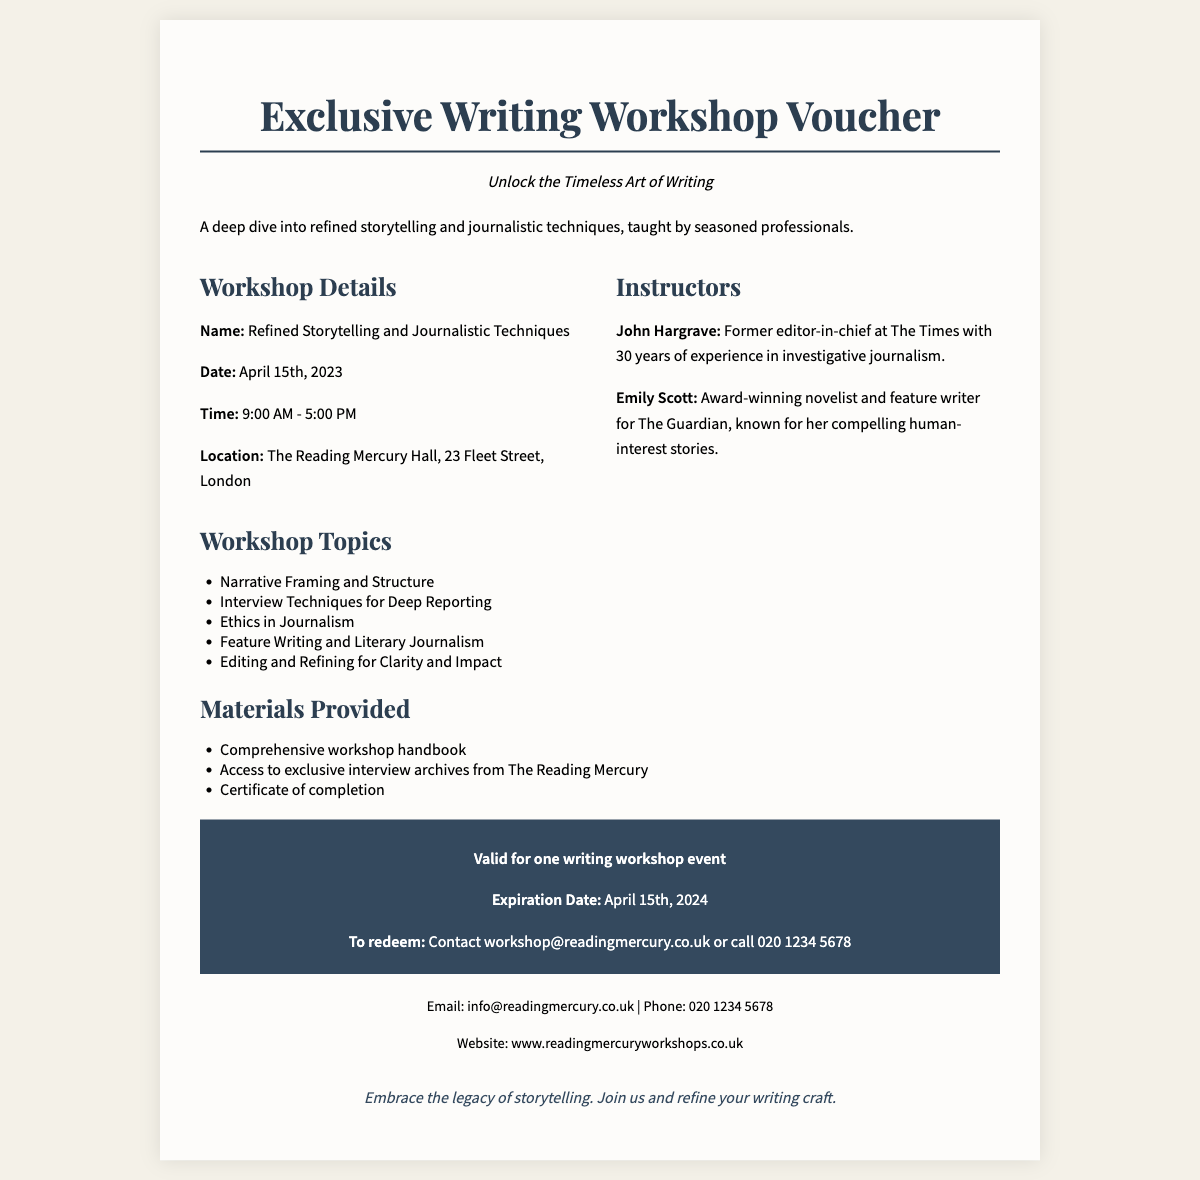What is the workshop name? The workshop name is found in the details section of the voucher document.
Answer: Refined Storytelling and Journalistic Techniques What is the date of the workshop? The date of the workshop is specifically stated in the details section.
Answer: April 15th, 2023 Who are the instructors? The instructors are listed under the instructors section of the document.
Answer: John Hargrave and Emily Scott What are the workshop hours? The workshop hours are mentioned in the details section, indicating the start and end time.
Answer: 9:00 AM - 5:00 PM What is the expiration date of the voucher? The expiration date is clearly mentioned in the validity section of the voucher.
Answer: April 15th, 2024 What materials will be provided? The materials provided are listed in a dedicated section of the document.
Answer: Comprehensive workshop handbook, Access to exclusive interview archives from The Reading Mercury, Certificate of completion Which skill will be focused on during the workshop? The skills/topics of the workshop are enumerated to highlight specific areas of focus.
Answer: Narrative Framing and Structure How can the voucher be redeemed? The redemption instructions are provided in the validity section for ease of understanding.
Answer: Contact workshop@readingmercury.co.uk or call 020 1234 5678 What is the location of the workshop? The location is detailed in the workshop details section for clarity.
Answer: The Reading Mercury Hall, 23 Fleet Street, London 